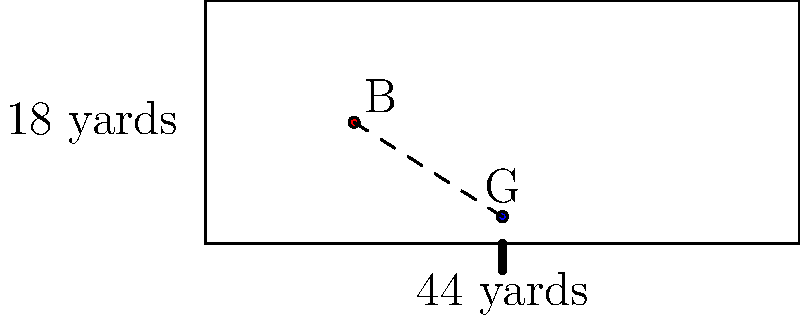In a standard football pitch, the penalty box measures 44 yards wide and 18 yards deep. The goalkeeper (G) is positioned 2 yards in front of the center of the goal line, and the ball (B) is located 11 yards from the left edge and 9 yards from the front of the penalty box. Calculate the area of the triangle formed by the goalkeeper's position, the ball's position, and the left front corner of the penalty box. How does this relate to the goalkeeper's positioning strategy? To solve this problem, we'll follow these steps:

1) First, let's identify the coordinates of the three points forming the triangle:
   - Goalkeeper (G): (22, 2)
   - Ball (B): (11, 9)
   - Left front corner of the penalty box: (0, 0)

2) We can use the formula for the area of a triangle given the coordinates of its vertices:
   Area = $\frac{1}{2}|x_1(y_2 - y_3) + x_2(y_3 - y_1) + x_3(y_1 - y_2)|$

   Where $(x_1, y_1)$, $(x_2, y_2)$, and $(x_3, y_3)$ are the coordinates of the three vertices.

3) Plugging in our values:
   Area = $\frac{1}{2}|22(9 - 0) + 11(0 - 2) + 0(2 - 9)|$
        = $\frac{1}{2}|22(9) + 11(-2) + 0(-7)|$
        = $\frac{1}{2}|198 - 22|$
        = $\frac{1}{2}(176)$
        = 88 square yards

4) Regarding the goalkeeper's positioning strategy:
   - The larger this triangle, the more area the goalkeeper is covering.
   - By positioning 2 yards in front of the goal line, the goalkeeper has created a larger triangle, effectively covering more of the penalty box.
   - This positioning allows the goalkeeper to intercept potential through balls or crosses more easily.
   - However, it also leaves more space behind for chip shots or lobs.

5) The goalkeeper must balance between covering more area and maintaining the ability to quickly retreat to the goal line if needed.
Answer: 88 square yards; larger triangle means more area covered but risk of being chipped. 